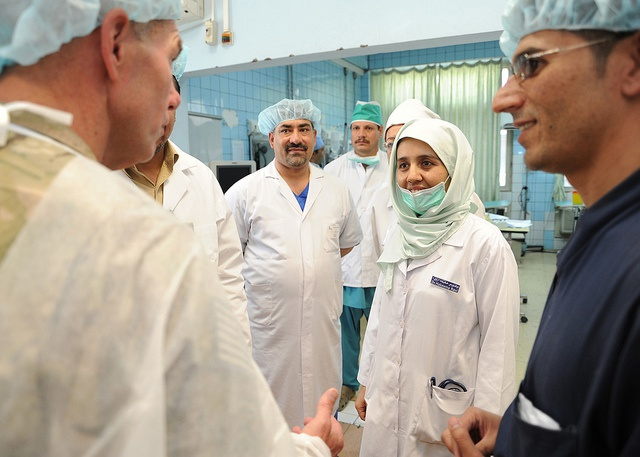Describe the objects in this image and their specific colors. I can see people in darkgray, tan, and beige tones, people in darkgray, black, and brown tones, people in darkgray and lightgray tones, people in darkgray, lightgray, and tan tones, and people in darkgray, lightgray, and teal tones in this image. 